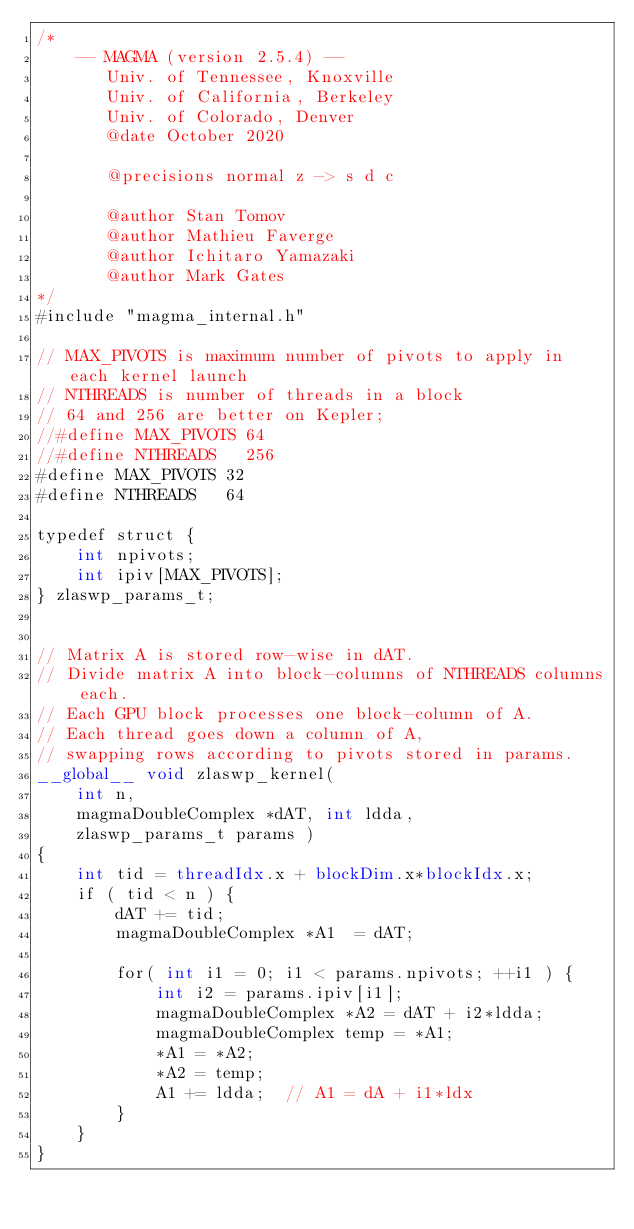<code> <loc_0><loc_0><loc_500><loc_500><_Cuda_>/*
    -- MAGMA (version 2.5.4) --
       Univ. of Tennessee, Knoxville
       Univ. of California, Berkeley
       Univ. of Colorado, Denver
       @date October 2020

       @precisions normal z -> s d c
       
       @author Stan Tomov
       @author Mathieu Faverge
       @author Ichitaro Yamazaki
       @author Mark Gates
*/
#include "magma_internal.h"

// MAX_PIVOTS is maximum number of pivots to apply in each kernel launch
// NTHREADS is number of threads in a block
// 64 and 256 are better on Kepler;
//#define MAX_PIVOTS 64
//#define NTHREADS   256
#define MAX_PIVOTS 32
#define NTHREADS   64

typedef struct {
    int npivots;
    int ipiv[MAX_PIVOTS];
} zlaswp_params_t;


// Matrix A is stored row-wise in dAT.
// Divide matrix A into block-columns of NTHREADS columns each.
// Each GPU block processes one block-column of A.
// Each thread goes down a column of A,
// swapping rows according to pivots stored in params.
__global__ void zlaswp_kernel(
    int n,
    magmaDoubleComplex *dAT, int ldda,
    zlaswp_params_t params )
{
    int tid = threadIdx.x + blockDim.x*blockIdx.x;
    if ( tid < n ) {
        dAT += tid;
        magmaDoubleComplex *A1  = dAT;
        
        for( int i1 = 0; i1 < params.npivots; ++i1 ) {
            int i2 = params.ipiv[i1];
            magmaDoubleComplex *A2 = dAT + i2*ldda;
            magmaDoubleComplex temp = *A1;
            *A1 = *A2;
            *A2 = temp;
            A1 += ldda;  // A1 = dA + i1*ldx
        }
    }
}

</code> 